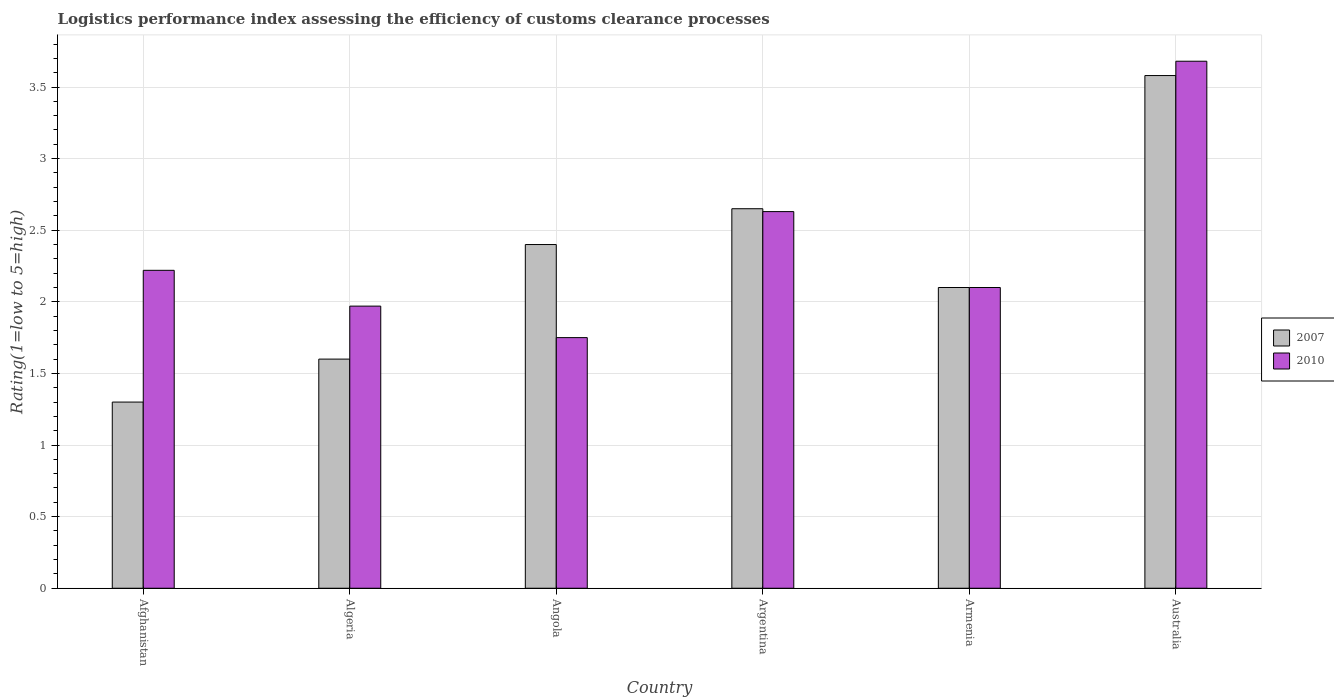How many groups of bars are there?
Make the answer very short. 6. Are the number of bars on each tick of the X-axis equal?
Offer a very short reply. Yes. How many bars are there on the 6th tick from the right?
Give a very brief answer. 2. What is the label of the 5th group of bars from the left?
Give a very brief answer. Armenia. In how many cases, is the number of bars for a given country not equal to the number of legend labels?
Keep it short and to the point. 0. What is the Logistic performance index in 2007 in Afghanistan?
Ensure brevity in your answer.  1.3. Across all countries, what is the maximum Logistic performance index in 2007?
Provide a short and direct response. 3.58. Across all countries, what is the minimum Logistic performance index in 2010?
Provide a succinct answer. 1.75. In which country was the Logistic performance index in 2010 maximum?
Your response must be concise. Australia. In which country was the Logistic performance index in 2010 minimum?
Offer a terse response. Angola. What is the total Logistic performance index in 2007 in the graph?
Make the answer very short. 13.63. What is the difference between the Logistic performance index in 2010 in Algeria and that in Argentina?
Ensure brevity in your answer.  -0.66. What is the difference between the Logistic performance index in 2007 in Afghanistan and the Logistic performance index in 2010 in Australia?
Provide a short and direct response. -2.38. What is the average Logistic performance index in 2007 per country?
Provide a short and direct response. 2.27. What is the difference between the Logistic performance index of/in 2007 and Logistic performance index of/in 2010 in Angola?
Your answer should be compact. 0.65. What is the ratio of the Logistic performance index in 2007 in Argentina to that in Australia?
Provide a succinct answer. 0.74. Is the difference between the Logistic performance index in 2007 in Algeria and Australia greater than the difference between the Logistic performance index in 2010 in Algeria and Australia?
Keep it short and to the point. No. What is the difference between the highest and the second highest Logistic performance index in 2010?
Offer a very short reply. -1.05. What is the difference between the highest and the lowest Logistic performance index in 2007?
Your answer should be very brief. 2.28. What does the 2nd bar from the right in Argentina represents?
Provide a succinct answer. 2007. What is the difference between two consecutive major ticks on the Y-axis?
Give a very brief answer. 0.5. Does the graph contain any zero values?
Offer a very short reply. No. Does the graph contain grids?
Offer a very short reply. Yes. Where does the legend appear in the graph?
Offer a terse response. Center right. What is the title of the graph?
Offer a very short reply. Logistics performance index assessing the efficiency of customs clearance processes. Does "1961" appear as one of the legend labels in the graph?
Your answer should be compact. No. What is the label or title of the X-axis?
Provide a succinct answer. Country. What is the label or title of the Y-axis?
Make the answer very short. Rating(1=low to 5=high). What is the Rating(1=low to 5=high) of 2007 in Afghanistan?
Give a very brief answer. 1.3. What is the Rating(1=low to 5=high) in 2010 in Afghanistan?
Ensure brevity in your answer.  2.22. What is the Rating(1=low to 5=high) of 2010 in Algeria?
Your answer should be very brief. 1.97. What is the Rating(1=low to 5=high) in 2007 in Angola?
Provide a short and direct response. 2.4. What is the Rating(1=low to 5=high) in 2007 in Argentina?
Ensure brevity in your answer.  2.65. What is the Rating(1=low to 5=high) in 2010 in Argentina?
Make the answer very short. 2.63. What is the Rating(1=low to 5=high) in 2007 in Armenia?
Offer a terse response. 2.1. What is the Rating(1=low to 5=high) of 2010 in Armenia?
Provide a short and direct response. 2.1. What is the Rating(1=low to 5=high) in 2007 in Australia?
Keep it short and to the point. 3.58. What is the Rating(1=low to 5=high) of 2010 in Australia?
Your answer should be compact. 3.68. Across all countries, what is the maximum Rating(1=low to 5=high) in 2007?
Your answer should be compact. 3.58. Across all countries, what is the maximum Rating(1=low to 5=high) in 2010?
Keep it short and to the point. 3.68. Across all countries, what is the minimum Rating(1=low to 5=high) of 2010?
Offer a terse response. 1.75. What is the total Rating(1=low to 5=high) in 2007 in the graph?
Make the answer very short. 13.63. What is the total Rating(1=low to 5=high) in 2010 in the graph?
Ensure brevity in your answer.  14.35. What is the difference between the Rating(1=low to 5=high) of 2007 in Afghanistan and that in Algeria?
Make the answer very short. -0.3. What is the difference between the Rating(1=low to 5=high) in 2010 in Afghanistan and that in Angola?
Offer a terse response. 0.47. What is the difference between the Rating(1=low to 5=high) in 2007 in Afghanistan and that in Argentina?
Offer a terse response. -1.35. What is the difference between the Rating(1=low to 5=high) of 2010 in Afghanistan and that in Argentina?
Your response must be concise. -0.41. What is the difference between the Rating(1=low to 5=high) of 2007 in Afghanistan and that in Armenia?
Your response must be concise. -0.8. What is the difference between the Rating(1=low to 5=high) in 2010 in Afghanistan and that in Armenia?
Your answer should be compact. 0.12. What is the difference between the Rating(1=low to 5=high) of 2007 in Afghanistan and that in Australia?
Offer a very short reply. -2.28. What is the difference between the Rating(1=low to 5=high) in 2010 in Afghanistan and that in Australia?
Your response must be concise. -1.46. What is the difference between the Rating(1=low to 5=high) of 2007 in Algeria and that in Angola?
Keep it short and to the point. -0.8. What is the difference between the Rating(1=low to 5=high) in 2010 in Algeria and that in Angola?
Make the answer very short. 0.22. What is the difference between the Rating(1=low to 5=high) in 2007 in Algeria and that in Argentina?
Give a very brief answer. -1.05. What is the difference between the Rating(1=low to 5=high) of 2010 in Algeria and that in Argentina?
Offer a very short reply. -0.66. What is the difference between the Rating(1=low to 5=high) of 2007 in Algeria and that in Armenia?
Make the answer very short. -0.5. What is the difference between the Rating(1=low to 5=high) in 2010 in Algeria and that in Armenia?
Offer a very short reply. -0.13. What is the difference between the Rating(1=low to 5=high) in 2007 in Algeria and that in Australia?
Provide a short and direct response. -1.98. What is the difference between the Rating(1=low to 5=high) in 2010 in Algeria and that in Australia?
Give a very brief answer. -1.71. What is the difference between the Rating(1=low to 5=high) in 2007 in Angola and that in Argentina?
Ensure brevity in your answer.  -0.25. What is the difference between the Rating(1=low to 5=high) in 2010 in Angola and that in Argentina?
Provide a short and direct response. -0.88. What is the difference between the Rating(1=low to 5=high) in 2007 in Angola and that in Armenia?
Your answer should be very brief. 0.3. What is the difference between the Rating(1=low to 5=high) in 2010 in Angola and that in Armenia?
Give a very brief answer. -0.35. What is the difference between the Rating(1=low to 5=high) in 2007 in Angola and that in Australia?
Offer a very short reply. -1.18. What is the difference between the Rating(1=low to 5=high) in 2010 in Angola and that in Australia?
Offer a terse response. -1.93. What is the difference between the Rating(1=low to 5=high) of 2007 in Argentina and that in Armenia?
Give a very brief answer. 0.55. What is the difference between the Rating(1=low to 5=high) of 2010 in Argentina and that in Armenia?
Offer a very short reply. 0.53. What is the difference between the Rating(1=low to 5=high) in 2007 in Argentina and that in Australia?
Make the answer very short. -0.93. What is the difference between the Rating(1=low to 5=high) in 2010 in Argentina and that in Australia?
Your response must be concise. -1.05. What is the difference between the Rating(1=low to 5=high) of 2007 in Armenia and that in Australia?
Your response must be concise. -1.48. What is the difference between the Rating(1=low to 5=high) in 2010 in Armenia and that in Australia?
Ensure brevity in your answer.  -1.58. What is the difference between the Rating(1=low to 5=high) in 2007 in Afghanistan and the Rating(1=low to 5=high) in 2010 in Algeria?
Your answer should be very brief. -0.67. What is the difference between the Rating(1=low to 5=high) of 2007 in Afghanistan and the Rating(1=low to 5=high) of 2010 in Angola?
Make the answer very short. -0.45. What is the difference between the Rating(1=low to 5=high) in 2007 in Afghanistan and the Rating(1=low to 5=high) in 2010 in Argentina?
Ensure brevity in your answer.  -1.33. What is the difference between the Rating(1=low to 5=high) of 2007 in Afghanistan and the Rating(1=low to 5=high) of 2010 in Australia?
Your answer should be very brief. -2.38. What is the difference between the Rating(1=low to 5=high) of 2007 in Algeria and the Rating(1=low to 5=high) of 2010 in Argentina?
Ensure brevity in your answer.  -1.03. What is the difference between the Rating(1=low to 5=high) of 2007 in Algeria and the Rating(1=low to 5=high) of 2010 in Armenia?
Provide a short and direct response. -0.5. What is the difference between the Rating(1=low to 5=high) of 2007 in Algeria and the Rating(1=low to 5=high) of 2010 in Australia?
Your answer should be compact. -2.08. What is the difference between the Rating(1=low to 5=high) of 2007 in Angola and the Rating(1=low to 5=high) of 2010 in Argentina?
Ensure brevity in your answer.  -0.23. What is the difference between the Rating(1=low to 5=high) in 2007 in Angola and the Rating(1=low to 5=high) in 2010 in Australia?
Give a very brief answer. -1.28. What is the difference between the Rating(1=low to 5=high) in 2007 in Argentina and the Rating(1=low to 5=high) in 2010 in Armenia?
Your answer should be compact. 0.55. What is the difference between the Rating(1=low to 5=high) of 2007 in Argentina and the Rating(1=low to 5=high) of 2010 in Australia?
Provide a succinct answer. -1.03. What is the difference between the Rating(1=low to 5=high) of 2007 in Armenia and the Rating(1=low to 5=high) of 2010 in Australia?
Make the answer very short. -1.58. What is the average Rating(1=low to 5=high) in 2007 per country?
Your response must be concise. 2.27. What is the average Rating(1=low to 5=high) of 2010 per country?
Provide a succinct answer. 2.39. What is the difference between the Rating(1=low to 5=high) of 2007 and Rating(1=low to 5=high) of 2010 in Afghanistan?
Give a very brief answer. -0.92. What is the difference between the Rating(1=low to 5=high) in 2007 and Rating(1=low to 5=high) in 2010 in Algeria?
Ensure brevity in your answer.  -0.37. What is the difference between the Rating(1=low to 5=high) in 2007 and Rating(1=low to 5=high) in 2010 in Angola?
Ensure brevity in your answer.  0.65. What is the difference between the Rating(1=low to 5=high) of 2007 and Rating(1=low to 5=high) of 2010 in Argentina?
Provide a short and direct response. 0.02. What is the difference between the Rating(1=low to 5=high) of 2007 and Rating(1=low to 5=high) of 2010 in Armenia?
Provide a succinct answer. 0. What is the difference between the Rating(1=low to 5=high) in 2007 and Rating(1=low to 5=high) in 2010 in Australia?
Ensure brevity in your answer.  -0.1. What is the ratio of the Rating(1=low to 5=high) in 2007 in Afghanistan to that in Algeria?
Provide a succinct answer. 0.81. What is the ratio of the Rating(1=low to 5=high) in 2010 in Afghanistan to that in Algeria?
Provide a short and direct response. 1.13. What is the ratio of the Rating(1=low to 5=high) in 2007 in Afghanistan to that in Angola?
Offer a terse response. 0.54. What is the ratio of the Rating(1=low to 5=high) of 2010 in Afghanistan to that in Angola?
Your answer should be compact. 1.27. What is the ratio of the Rating(1=low to 5=high) of 2007 in Afghanistan to that in Argentina?
Make the answer very short. 0.49. What is the ratio of the Rating(1=low to 5=high) in 2010 in Afghanistan to that in Argentina?
Offer a very short reply. 0.84. What is the ratio of the Rating(1=low to 5=high) of 2007 in Afghanistan to that in Armenia?
Ensure brevity in your answer.  0.62. What is the ratio of the Rating(1=low to 5=high) in 2010 in Afghanistan to that in Armenia?
Your response must be concise. 1.06. What is the ratio of the Rating(1=low to 5=high) of 2007 in Afghanistan to that in Australia?
Provide a succinct answer. 0.36. What is the ratio of the Rating(1=low to 5=high) of 2010 in Afghanistan to that in Australia?
Give a very brief answer. 0.6. What is the ratio of the Rating(1=low to 5=high) in 2007 in Algeria to that in Angola?
Provide a succinct answer. 0.67. What is the ratio of the Rating(1=low to 5=high) in 2010 in Algeria to that in Angola?
Give a very brief answer. 1.13. What is the ratio of the Rating(1=low to 5=high) in 2007 in Algeria to that in Argentina?
Your answer should be compact. 0.6. What is the ratio of the Rating(1=low to 5=high) of 2010 in Algeria to that in Argentina?
Give a very brief answer. 0.75. What is the ratio of the Rating(1=low to 5=high) of 2007 in Algeria to that in Armenia?
Your answer should be compact. 0.76. What is the ratio of the Rating(1=low to 5=high) of 2010 in Algeria to that in Armenia?
Your response must be concise. 0.94. What is the ratio of the Rating(1=low to 5=high) in 2007 in Algeria to that in Australia?
Provide a succinct answer. 0.45. What is the ratio of the Rating(1=low to 5=high) of 2010 in Algeria to that in Australia?
Keep it short and to the point. 0.54. What is the ratio of the Rating(1=low to 5=high) of 2007 in Angola to that in Argentina?
Keep it short and to the point. 0.91. What is the ratio of the Rating(1=low to 5=high) in 2010 in Angola to that in Argentina?
Provide a succinct answer. 0.67. What is the ratio of the Rating(1=low to 5=high) of 2010 in Angola to that in Armenia?
Make the answer very short. 0.83. What is the ratio of the Rating(1=low to 5=high) in 2007 in Angola to that in Australia?
Ensure brevity in your answer.  0.67. What is the ratio of the Rating(1=low to 5=high) of 2010 in Angola to that in Australia?
Ensure brevity in your answer.  0.48. What is the ratio of the Rating(1=low to 5=high) of 2007 in Argentina to that in Armenia?
Provide a succinct answer. 1.26. What is the ratio of the Rating(1=low to 5=high) of 2010 in Argentina to that in Armenia?
Offer a terse response. 1.25. What is the ratio of the Rating(1=low to 5=high) of 2007 in Argentina to that in Australia?
Give a very brief answer. 0.74. What is the ratio of the Rating(1=low to 5=high) in 2010 in Argentina to that in Australia?
Your answer should be compact. 0.71. What is the ratio of the Rating(1=low to 5=high) of 2007 in Armenia to that in Australia?
Your response must be concise. 0.59. What is the ratio of the Rating(1=low to 5=high) in 2010 in Armenia to that in Australia?
Make the answer very short. 0.57. What is the difference between the highest and the second highest Rating(1=low to 5=high) of 2010?
Provide a succinct answer. 1.05. What is the difference between the highest and the lowest Rating(1=low to 5=high) in 2007?
Your answer should be very brief. 2.28. What is the difference between the highest and the lowest Rating(1=low to 5=high) of 2010?
Make the answer very short. 1.93. 